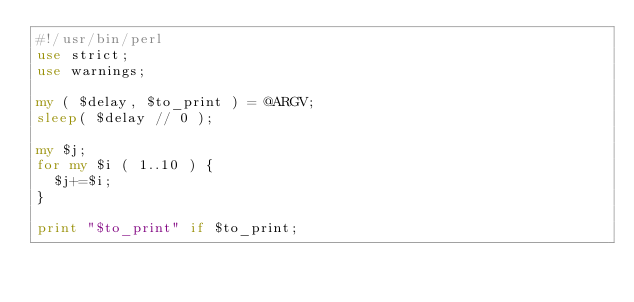Convert code to text. <code><loc_0><loc_0><loc_500><loc_500><_Perl_>#!/usr/bin/perl
use strict;
use warnings;

my ( $delay, $to_print ) = @ARGV;
sleep( $delay // 0 );

my $j;
for my $i ( 1..10 ) {
	$j+=$i;
}

print "$to_print" if $to_print;
</code> 